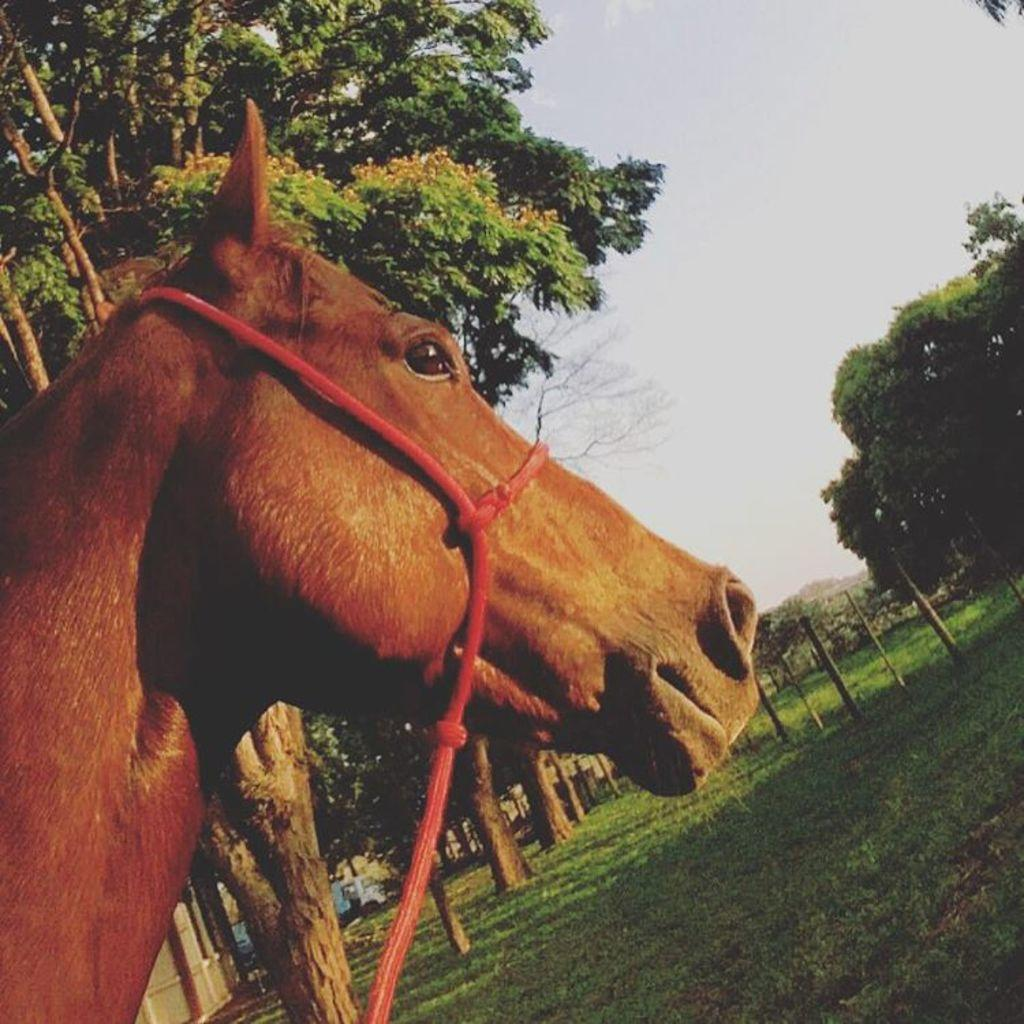What animal is present in the image? There is a horse in the image. What is the color of the horse? The horse is brown in color. What type of vegetation can be seen in the image? There are trees visible in the image. What is the ground covered with in the image? There is grass on the ground in the image. How would you describe the sky in the image? The sky is cloudy in the image. What type of cord is used to control the horse's movements in the image? There is no cord present in the image, and the horse's movements are not controlled by any visible means. 